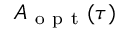<formula> <loc_0><loc_0><loc_500><loc_500>A _ { o p t } ( \tau )</formula> 